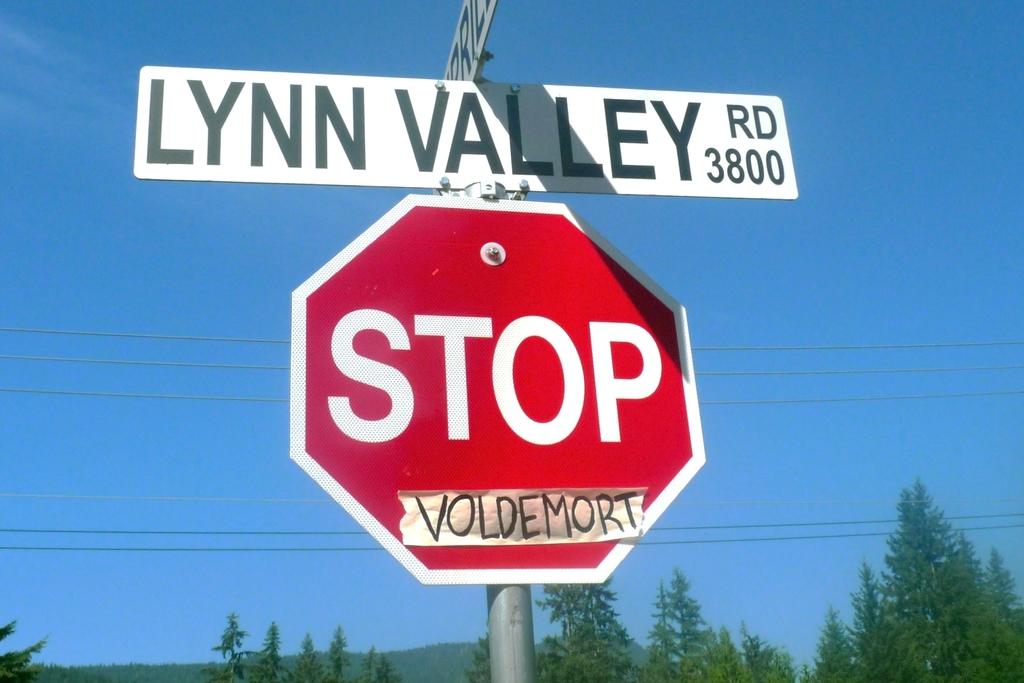What is the street name?
Keep it short and to the point. Lynn valley. Is that a stop sign?
Your answer should be very brief. Yes. 